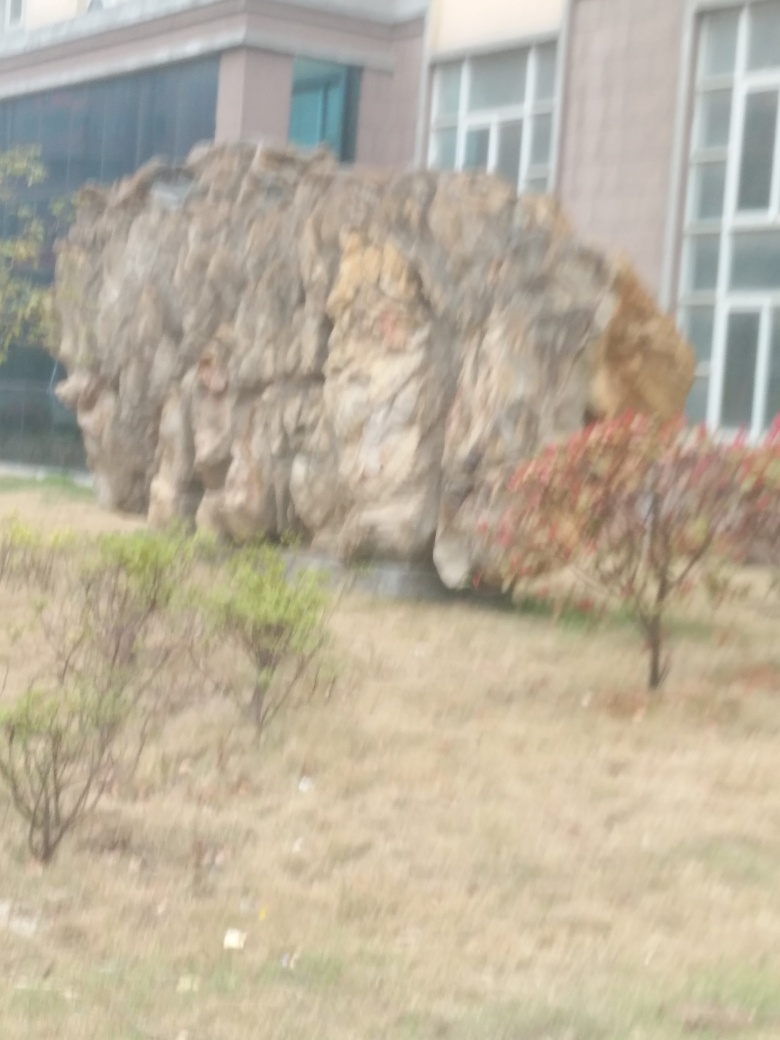How might the weather or season affect the appearance of this setting? In different seasons or weather conditions, the appearance of this environment would change distinctly. During spring or summer, the greenery might become more vibrant and lush, while in autumn, the foliage could turn into warm shades of yellow, orange, or red. Winter might bring a stark, bare look to the vegetation and possibly cover the area with snow, drastically altering the landscape's aesthetic. 